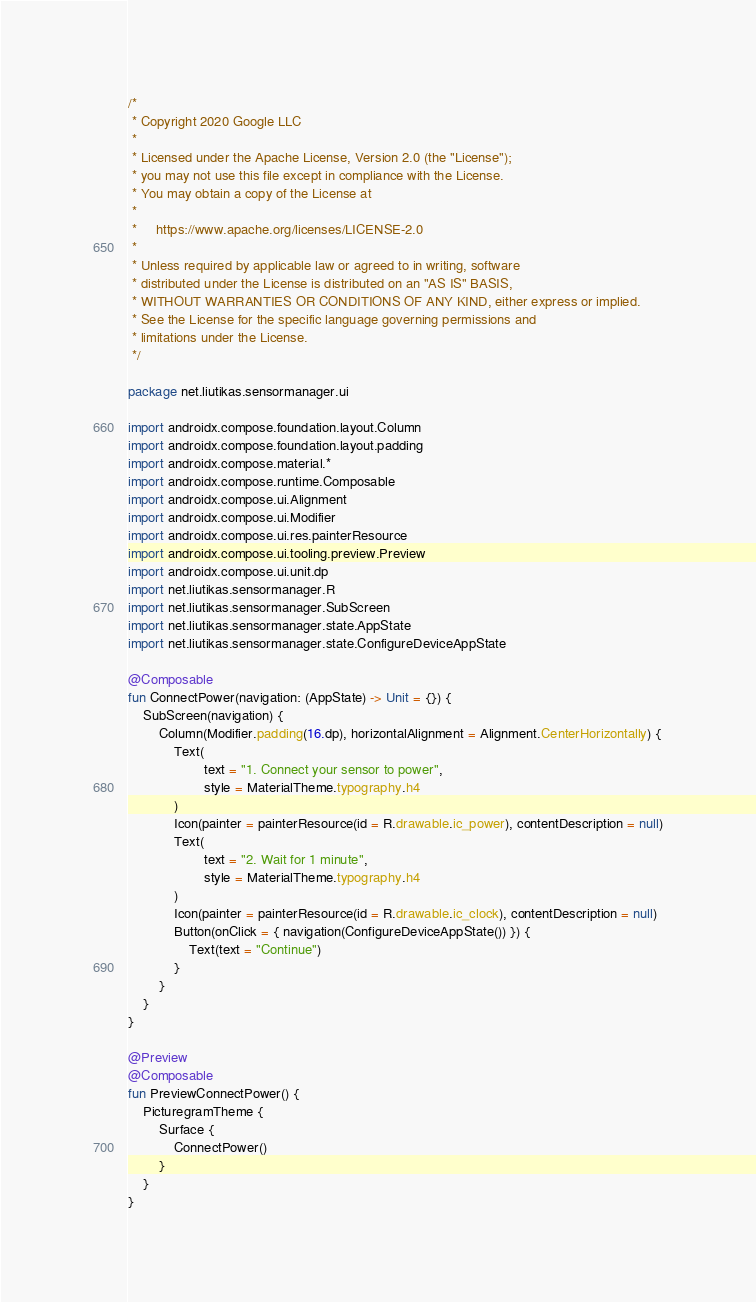Convert code to text. <code><loc_0><loc_0><loc_500><loc_500><_Kotlin_>/*
 * Copyright 2020 Google LLC
 *
 * Licensed under the Apache License, Version 2.0 (the "License");
 * you may not use this file except in compliance with the License.
 * You may obtain a copy of the License at
 *
 *     https://www.apache.org/licenses/LICENSE-2.0
 *
 * Unless required by applicable law or agreed to in writing, software
 * distributed under the License is distributed on an "AS IS" BASIS,
 * WITHOUT WARRANTIES OR CONDITIONS OF ANY KIND, either express or implied.
 * See the License for the specific language governing permissions and
 * limitations under the License.
 */

package net.liutikas.sensormanager.ui

import androidx.compose.foundation.layout.Column
import androidx.compose.foundation.layout.padding
import androidx.compose.material.*
import androidx.compose.runtime.Composable
import androidx.compose.ui.Alignment
import androidx.compose.ui.Modifier
import androidx.compose.ui.res.painterResource
import androidx.compose.ui.tooling.preview.Preview
import androidx.compose.ui.unit.dp
import net.liutikas.sensormanager.R
import net.liutikas.sensormanager.SubScreen
import net.liutikas.sensormanager.state.AppState
import net.liutikas.sensormanager.state.ConfigureDeviceAppState

@Composable
fun ConnectPower(navigation: (AppState) -> Unit = {}) {
    SubScreen(navigation) {
        Column(Modifier.padding(16.dp), horizontalAlignment = Alignment.CenterHorizontally) {
            Text(
                    text = "1. Connect your sensor to power",
                    style = MaterialTheme.typography.h4
            )
            Icon(painter = painterResource(id = R.drawable.ic_power), contentDescription = null)
            Text(
                    text = "2. Wait for 1 minute",
                    style = MaterialTheme.typography.h4
            )
            Icon(painter = painterResource(id = R.drawable.ic_clock), contentDescription = null)
            Button(onClick = { navigation(ConfigureDeviceAppState()) }) {
                Text(text = "Continue")
            }
        }
    }
}

@Preview
@Composable
fun PreviewConnectPower() {
    PicturegramTheme {
        Surface {
            ConnectPower()
        }
    }
}</code> 